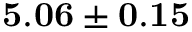Convert formula to latex. <formula><loc_0><loc_0><loc_500><loc_500>{ 5 . 0 6 \pm 0 . 1 5 }</formula> 